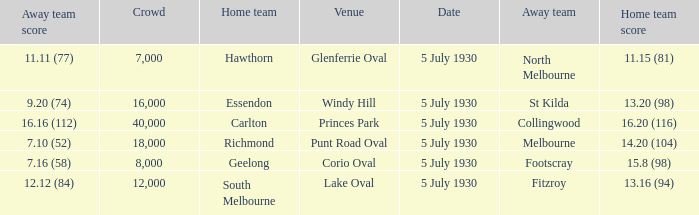Who is the away side at corio oval? Footscray. 